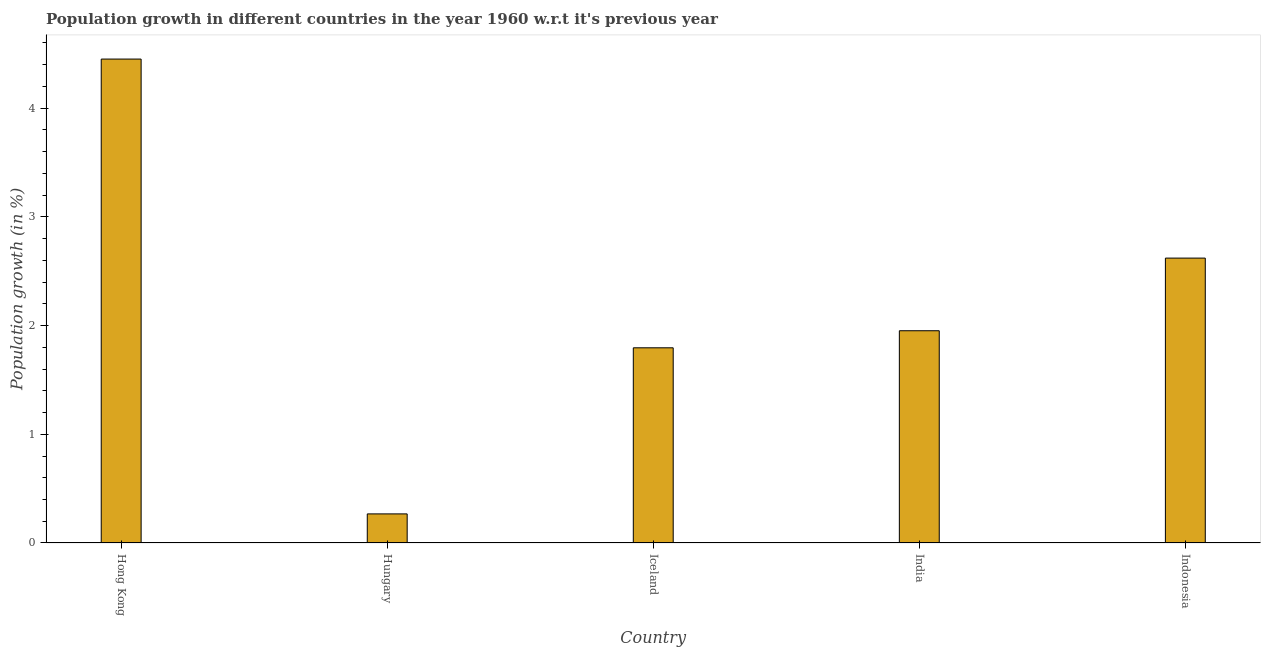Does the graph contain grids?
Make the answer very short. No. What is the title of the graph?
Ensure brevity in your answer.  Population growth in different countries in the year 1960 w.r.t it's previous year. What is the label or title of the Y-axis?
Your answer should be compact. Population growth (in %). What is the population growth in Hungary?
Your answer should be very brief. 0.27. Across all countries, what is the maximum population growth?
Keep it short and to the point. 4.45. Across all countries, what is the minimum population growth?
Keep it short and to the point. 0.27. In which country was the population growth maximum?
Provide a short and direct response. Hong Kong. In which country was the population growth minimum?
Your answer should be very brief. Hungary. What is the sum of the population growth?
Offer a very short reply. 11.09. What is the difference between the population growth in Hungary and Indonesia?
Give a very brief answer. -2.35. What is the average population growth per country?
Provide a succinct answer. 2.22. What is the median population growth?
Provide a short and direct response. 1.95. What is the ratio of the population growth in Hungary to that in Iceland?
Provide a succinct answer. 0.15. Is the population growth in Hong Kong less than that in Indonesia?
Ensure brevity in your answer.  No. Is the difference between the population growth in Hong Kong and Hungary greater than the difference between any two countries?
Offer a terse response. Yes. What is the difference between the highest and the second highest population growth?
Provide a succinct answer. 1.83. What is the difference between the highest and the lowest population growth?
Provide a short and direct response. 4.18. In how many countries, is the population growth greater than the average population growth taken over all countries?
Provide a succinct answer. 2. How many countries are there in the graph?
Your answer should be compact. 5. What is the Population growth (in %) of Hong Kong?
Keep it short and to the point. 4.45. What is the Population growth (in %) of Hungary?
Provide a short and direct response. 0.27. What is the Population growth (in %) in Iceland?
Your response must be concise. 1.8. What is the Population growth (in %) in India?
Provide a succinct answer. 1.95. What is the Population growth (in %) in Indonesia?
Provide a short and direct response. 2.62. What is the difference between the Population growth (in %) in Hong Kong and Hungary?
Give a very brief answer. 4.18. What is the difference between the Population growth (in %) in Hong Kong and Iceland?
Keep it short and to the point. 2.66. What is the difference between the Population growth (in %) in Hong Kong and India?
Provide a succinct answer. 2.5. What is the difference between the Population growth (in %) in Hong Kong and Indonesia?
Keep it short and to the point. 1.83. What is the difference between the Population growth (in %) in Hungary and Iceland?
Your answer should be compact. -1.53. What is the difference between the Population growth (in %) in Hungary and India?
Ensure brevity in your answer.  -1.68. What is the difference between the Population growth (in %) in Hungary and Indonesia?
Keep it short and to the point. -2.35. What is the difference between the Population growth (in %) in Iceland and India?
Your answer should be compact. -0.16. What is the difference between the Population growth (in %) in Iceland and Indonesia?
Offer a very short reply. -0.82. What is the difference between the Population growth (in %) in India and Indonesia?
Ensure brevity in your answer.  -0.67. What is the ratio of the Population growth (in %) in Hong Kong to that in Hungary?
Offer a terse response. 16.64. What is the ratio of the Population growth (in %) in Hong Kong to that in Iceland?
Your response must be concise. 2.48. What is the ratio of the Population growth (in %) in Hong Kong to that in India?
Give a very brief answer. 2.28. What is the ratio of the Population growth (in %) in Hong Kong to that in Indonesia?
Give a very brief answer. 1.7. What is the ratio of the Population growth (in %) in Hungary to that in Iceland?
Give a very brief answer. 0.15. What is the ratio of the Population growth (in %) in Hungary to that in India?
Provide a short and direct response. 0.14. What is the ratio of the Population growth (in %) in Hungary to that in Indonesia?
Ensure brevity in your answer.  0.1. What is the ratio of the Population growth (in %) in Iceland to that in India?
Ensure brevity in your answer.  0.92. What is the ratio of the Population growth (in %) in Iceland to that in Indonesia?
Keep it short and to the point. 0.69. What is the ratio of the Population growth (in %) in India to that in Indonesia?
Offer a terse response. 0.74. 